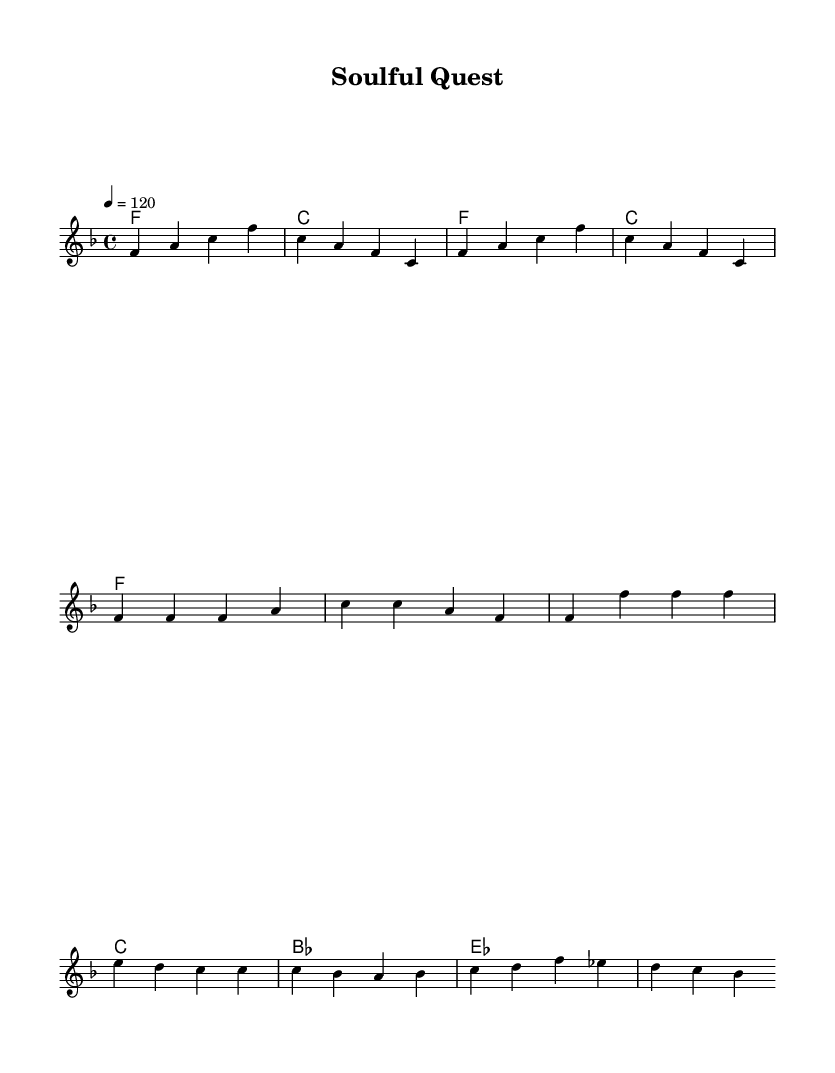What is the key signature of this music? The key signature is F major, which has one flat. This can be identified by looking at the key signature at the beginning of the piece, where a flat symbol appears on the B line.
Answer: F major What is the time signature of this music? The time signature is 4/4, indicated at the beginning of the score. This means there are four beats in each measure, and the quarter note gets one beat.
Answer: 4/4 What is the tempo marking of this piece? The tempo marking indicates 120 beats per minute, as displayed at the beginning of the score. This provides a guideline for the speed at which the piece should be played.
Answer: 120 What is the first chord played in the intro? The first chord is an F major chord, represented by the symbol for F on the staff. This chord establishes the tonal center for the piece.
Answer: F How many measures are in the chorus section (partial)? The chorus section provided contains two measures as indicated by the notation following the verse. This can be counted visually on the sheet music.
Answer: 2 How does the melody move in the bridge section? In the bridge section, the melody ascends from B flat to D and then to F, indicating an upward movement in pitch. This can be traced through the note placement on the staff.
Answer: Ascends What emotion do the repeated notes in the verse convey? The repeated notes in the verse convey a sense of persistence and determination, characteristic of the soul genre. This emotional interpretation stems from the nature of the rhythmic repetition in the melody.
Answer: Persistence 